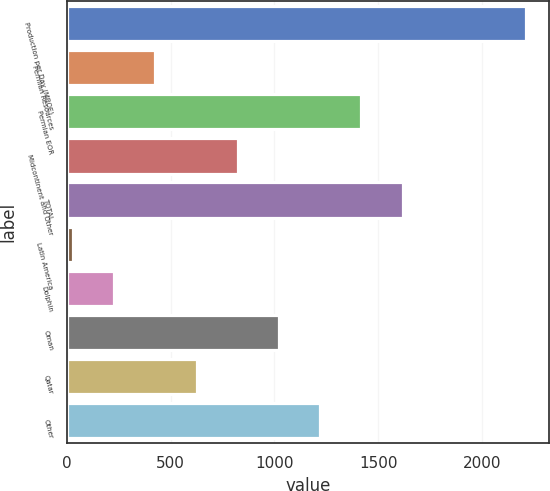Convert chart to OTSL. <chart><loc_0><loc_0><loc_500><loc_500><bar_chart><fcel>Production per Day (MBOE)<fcel>Permian Resources<fcel>Permian EOR<fcel>Midcontinent and Other<fcel>TOTAL<fcel>Latin America<fcel>Dolphin<fcel>Oman<fcel>Qatar<fcel>Other<nl><fcel>2211.2<fcel>427.4<fcel>1418.4<fcel>823.8<fcel>1616.6<fcel>31<fcel>229.2<fcel>1022<fcel>625.6<fcel>1220.2<nl></chart> 